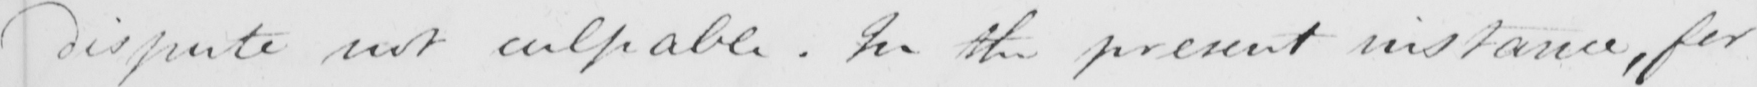What does this handwritten line say? dispute not culpable . In the present instance , for 